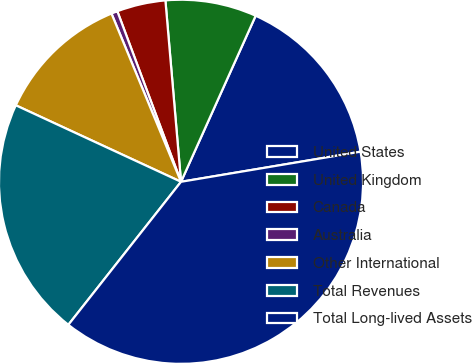Convert chart. <chart><loc_0><loc_0><loc_500><loc_500><pie_chart><fcel>United States<fcel>United Kingdom<fcel>Canada<fcel>Australia<fcel>Other International<fcel>Total Revenues<fcel>Total Long-lived Assets<nl><fcel>15.63%<fcel>8.09%<fcel>4.32%<fcel>0.55%<fcel>11.86%<fcel>21.28%<fcel>38.26%<nl></chart> 